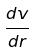Convert formula to latex. <formula><loc_0><loc_0><loc_500><loc_500>\frac { d v } { d r }</formula> 